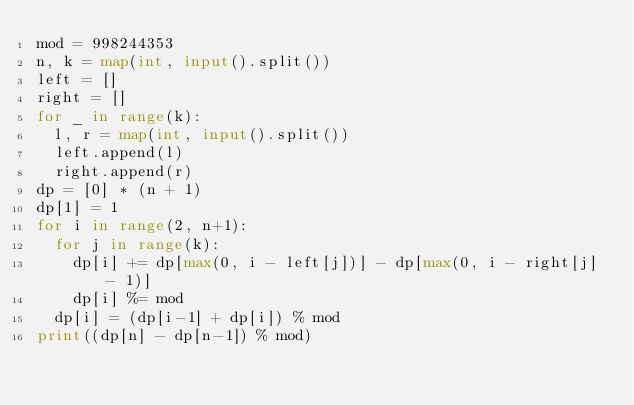<code> <loc_0><loc_0><loc_500><loc_500><_Python_>mod = 998244353
n, k = map(int, input().split())
left = []
right = []
for _ in range(k):
  l, r = map(int, input().split())
  left.append(l)
  right.append(r)
dp = [0] * (n + 1)
dp[1] = 1
for i in range(2, n+1):
  for j in range(k):
    dp[i] += dp[max(0, i - left[j])] - dp[max(0, i - right[j] - 1)]
    dp[i] %= mod
  dp[i] = (dp[i-1] + dp[i]) % mod
print((dp[n] - dp[n-1]) % mod)</code> 